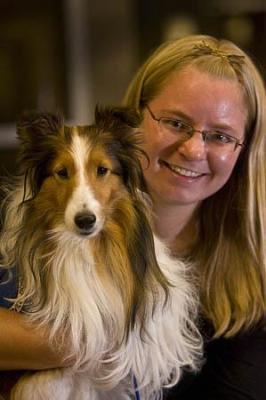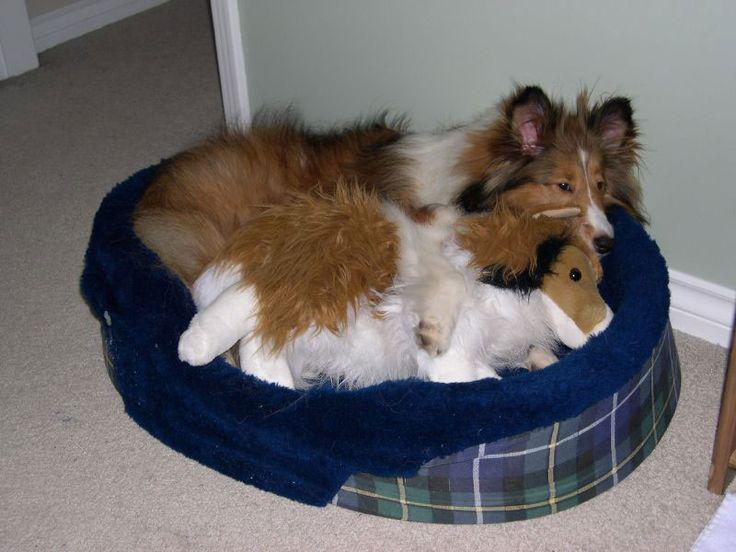The first image is the image on the left, the second image is the image on the right. For the images displayed, is the sentence "One dog photo is taken outside in a grassy area, while the other is taken inside in a private home setting." factually correct? Answer yes or no. No. The first image is the image on the left, the second image is the image on the right. For the images shown, is this caption "An image shows a woman in black next to at least one collie dog." true? Answer yes or no. Yes. 